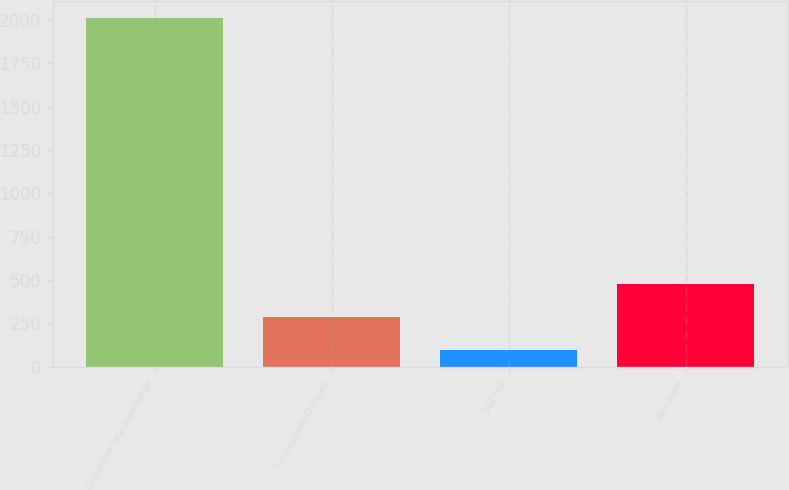<chart> <loc_0><loc_0><loc_500><loc_500><bar_chart><fcel>Cumulative Total Shareholder<fcel>Genuine Parts Company<fcel>S&P 500<fcel>Peer Index<nl><fcel>2009<fcel>288.48<fcel>97.31<fcel>479.65<nl></chart> 